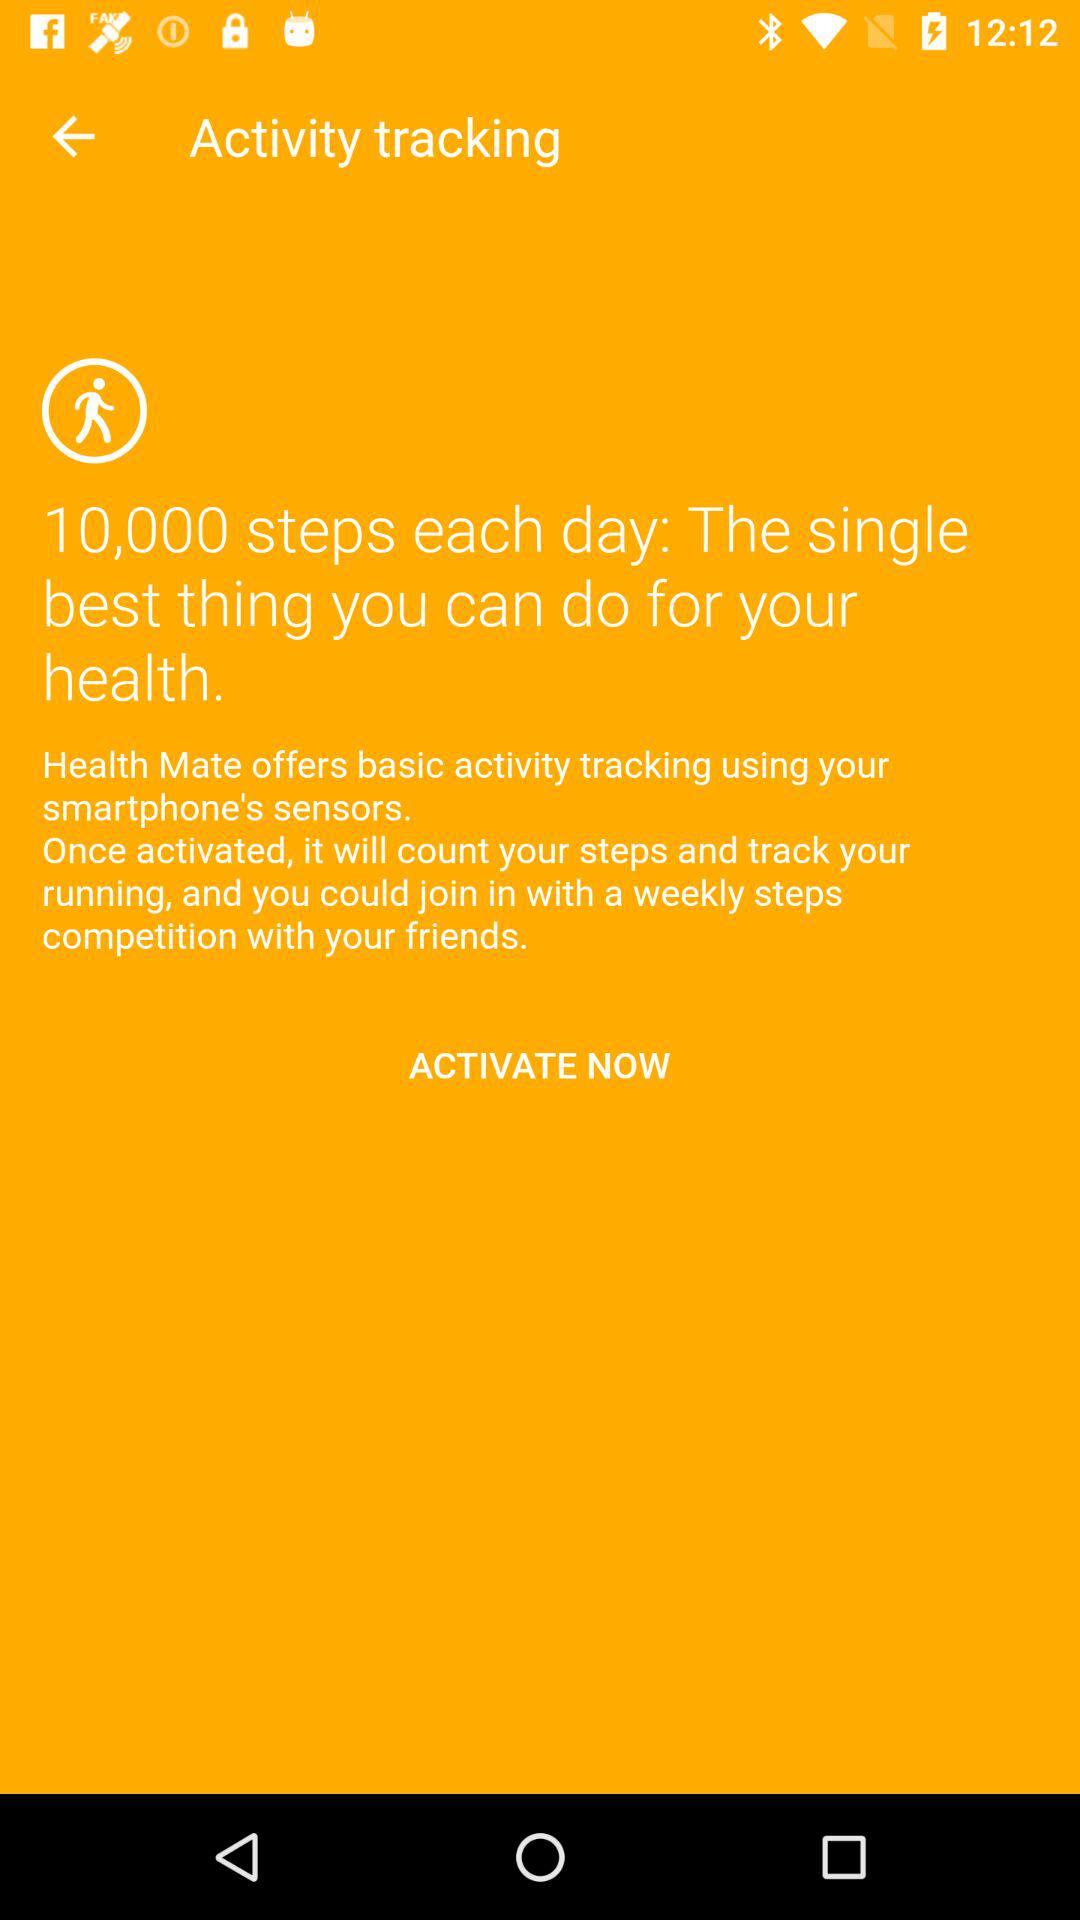How many steps do you need to take each day to be healthy?
Answer the question using a single word or phrase. 10,000 